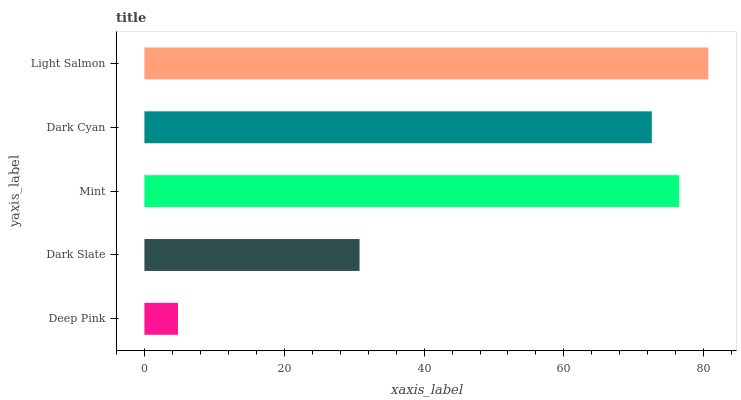Is Deep Pink the minimum?
Answer yes or no. Yes. Is Light Salmon the maximum?
Answer yes or no. Yes. Is Dark Slate the minimum?
Answer yes or no. No. Is Dark Slate the maximum?
Answer yes or no. No. Is Dark Slate greater than Deep Pink?
Answer yes or no. Yes. Is Deep Pink less than Dark Slate?
Answer yes or no. Yes. Is Deep Pink greater than Dark Slate?
Answer yes or no. No. Is Dark Slate less than Deep Pink?
Answer yes or no. No. Is Dark Cyan the high median?
Answer yes or no. Yes. Is Dark Cyan the low median?
Answer yes or no. Yes. Is Light Salmon the high median?
Answer yes or no. No. Is Dark Slate the low median?
Answer yes or no. No. 